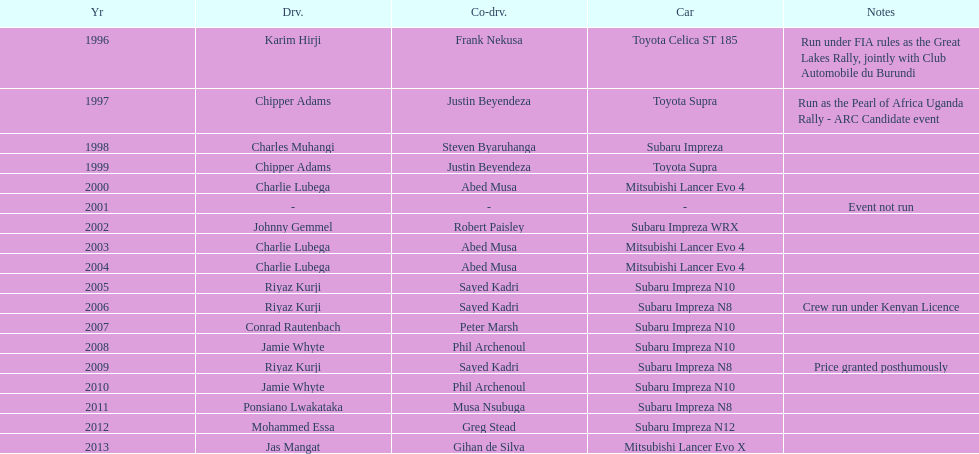What is the count of times a toyota supra has been driven by the champion driver? 2. 